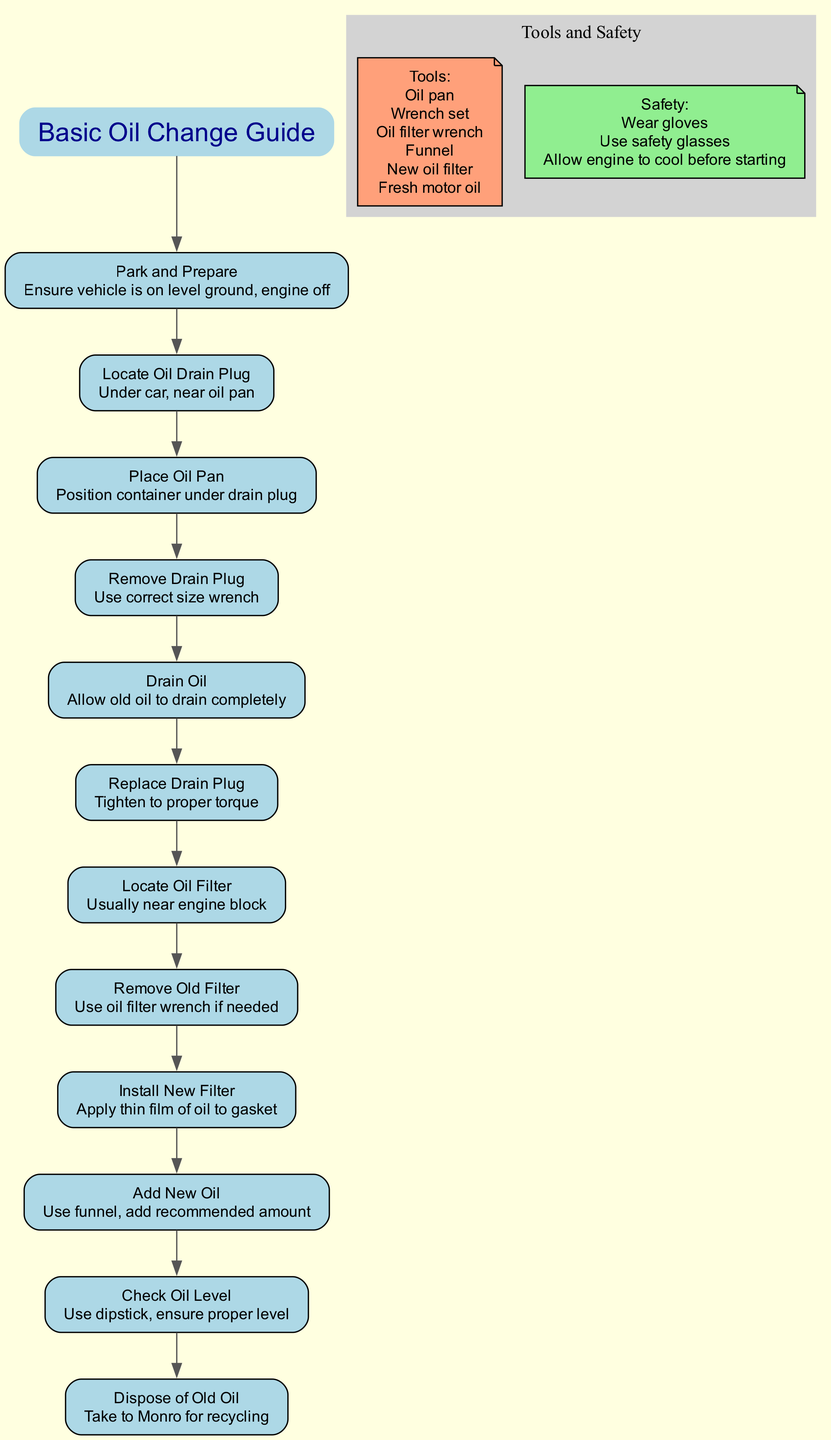What is the first step in the oil change process? The first step listed in the diagram is "Park and Prepare," which indicates to ensure the vehicle is on level ground and the engine is off.
Answer: Park and Prepare How many tools are listed in the diagram? The diagram mentions six tools required for the oil change process: oil pan, wrench set, oil filter wrench, funnel, new oil filter, and fresh motor oil. Counting these gives the total.
Answer: 6 Which step involves checking the oil level? The step that mentions checking the oil level is "Check Oil Level," which instructs to use the dipstick to ensure the proper level.
Answer: Check Oil Level What safety precaution is mentioned in the diagram? One of the safety precautions listed in the diagram is to "Wear gloves," as a protective measure during the oil change process.
Answer: Wear gloves What is done after draining the oil? After draining the oil, the next step in the process is to "Replace Drain Plug," which involves tightening it to the proper torque.
Answer: Replace Drain Plug Which two steps are related to the oil filter? The steps related to the oil filter are "Remove Old Filter" and "Install New Filter." These two steps involve removing the old oil filter and then installing a new one.
Answer: Remove Old Filter, Install New Filter What should be done with the old oil after changing it? The diagram advises to dispose of the old oil by taking it to Monro for recycling, which ensures proper disposal.
Answer: Take to Monro for recycling What step comes after adding new oil? The next step after adding new oil is "Check Oil Level," where you use a dipstick to ensure the oil level is proper.
Answer: Check Oil Level How is the new oil filter prepared for installation? Before installing the new oil filter, you should apply a thin film of oil to the gasket to ensure a proper seal.
Answer: Apply thin film of oil to gasket 